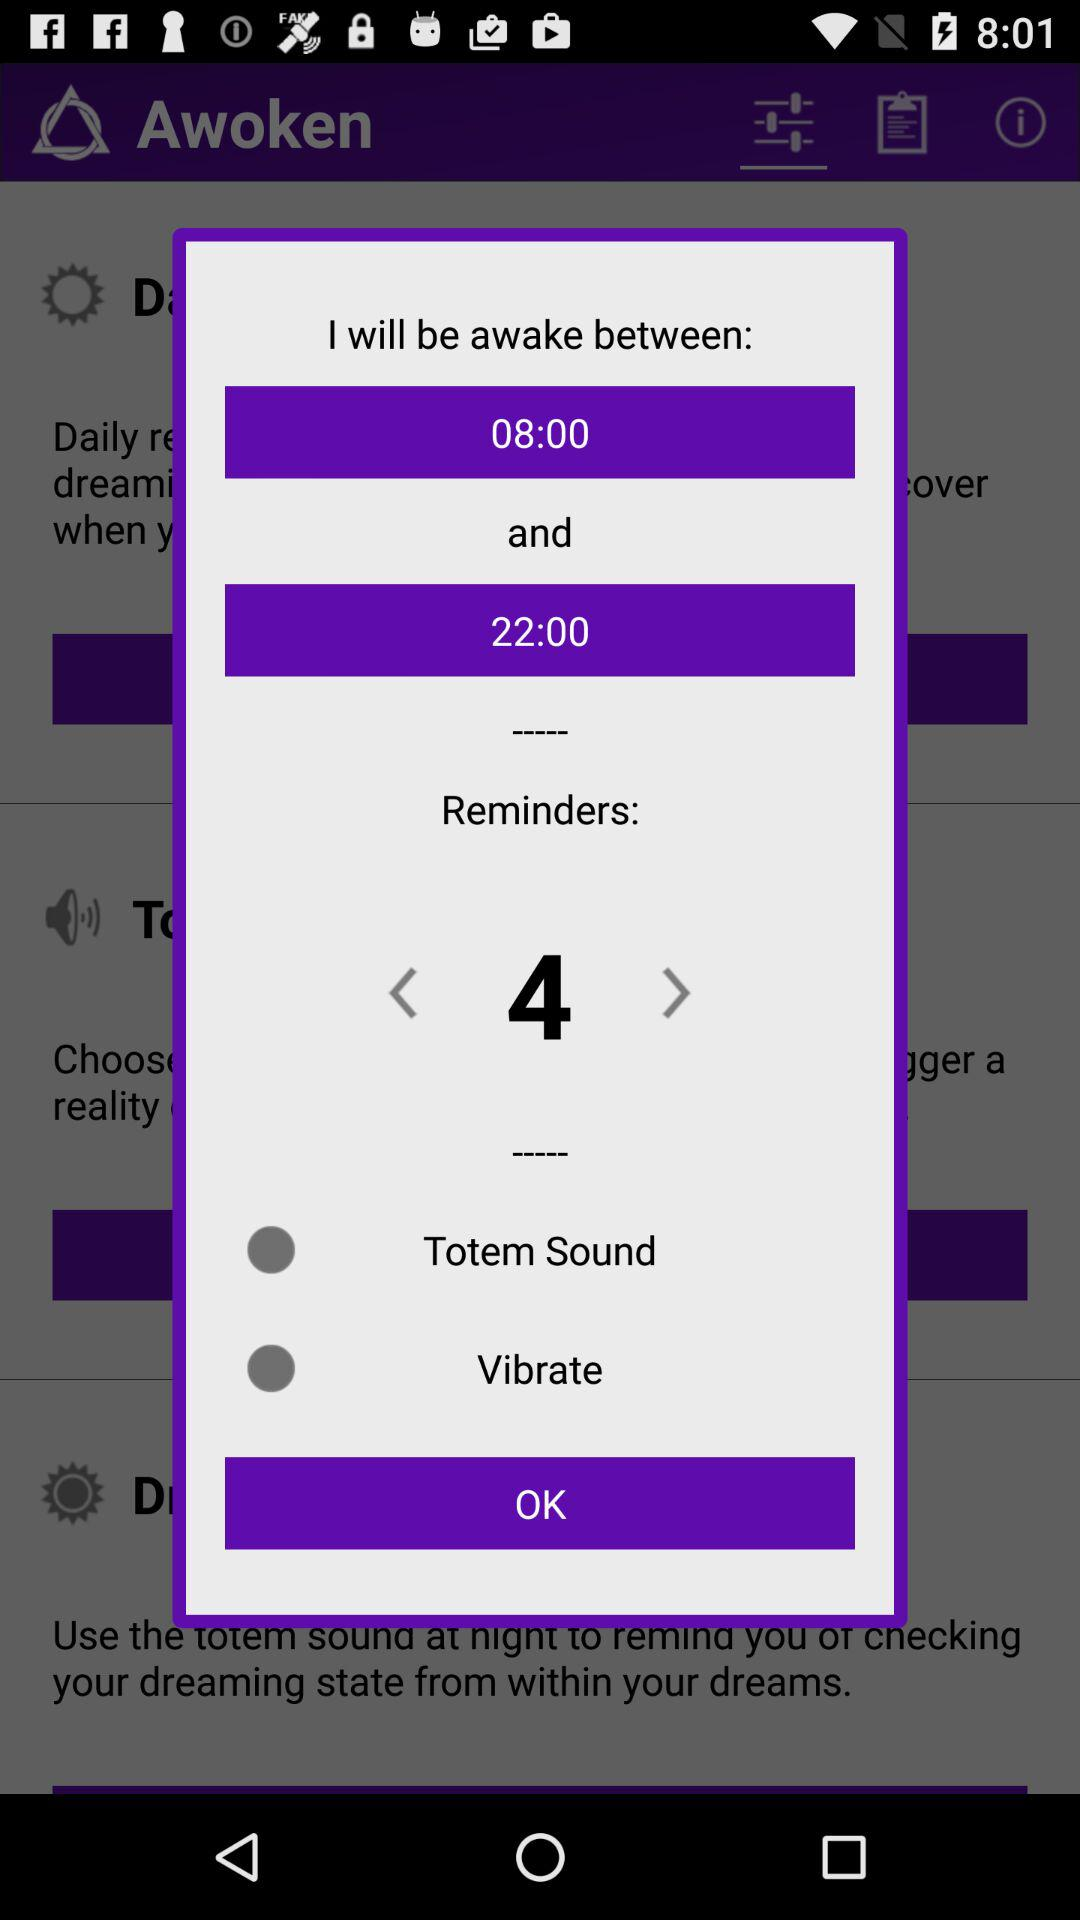When is the reminder time? The reminder times are at 08:00 and 22:00. 